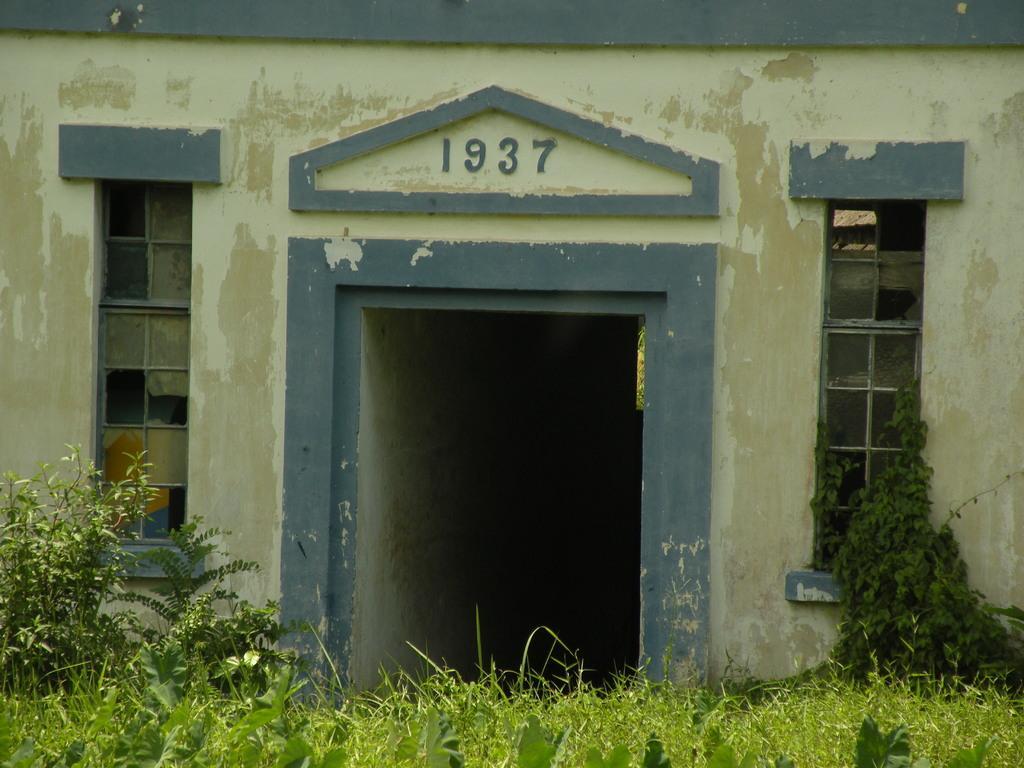How would you summarize this image in a sentence or two? In the picture I can see a house which has something written on it. In the front of the image I can see plants and some other objects. 